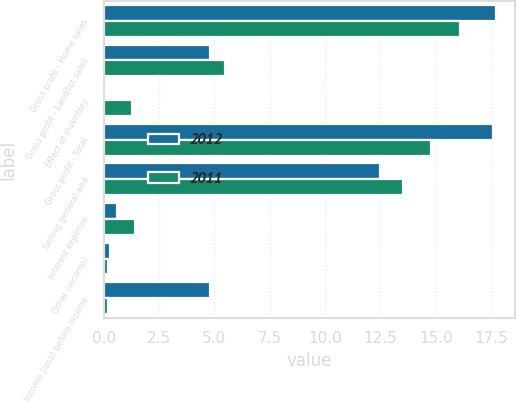Convert chart to OTSL. <chart><loc_0><loc_0><loc_500><loc_500><stacked_bar_chart><ecel><fcel>Gross profit - Home sales<fcel>Gross profit - Land/lot sales<fcel>Effect of inventory<fcel>Gross profit - Total<fcel>Selling general and<fcel>Interest expense<fcel>Other (income)<fcel>Income (loss) before income<nl><fcel>2012<fcel>17.7<fcel>4.8<fcel>0.1<fcel>17.6<fcel>12.5<fcel>0.6<fcel>0.3<fcel>4.8<nl><fcel>2011<fcel>16.1<fcel>5.5<fcel>1.3<fcel>14.8<fcel>13.5<fcel>1.4<fcel>0.2<fcel>0.2<nl></chart> 